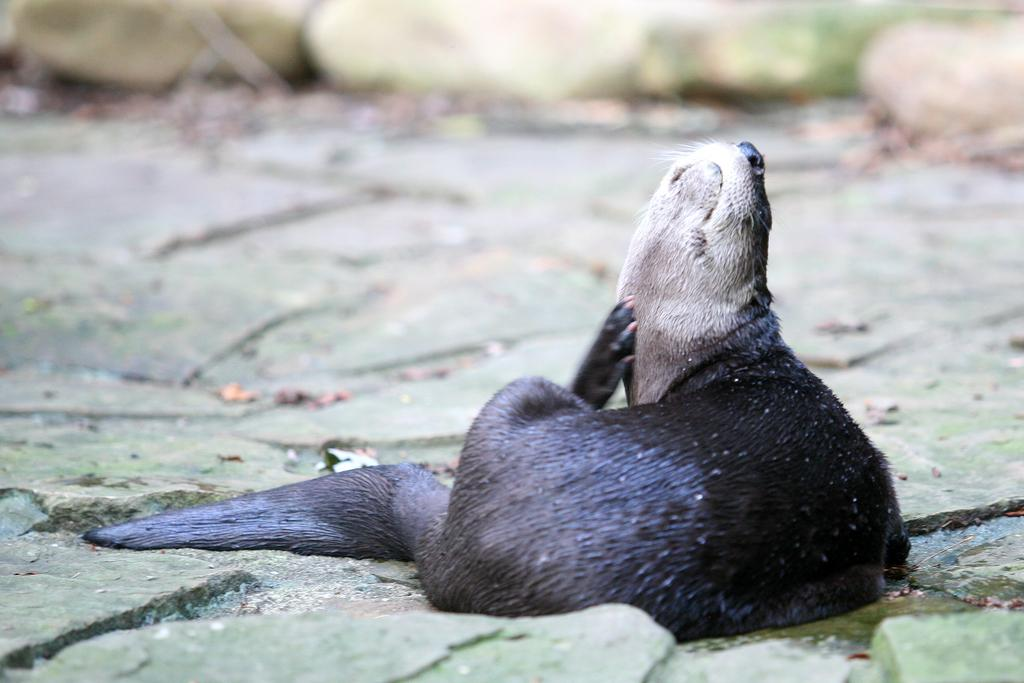What type of animal is in the image? There is a California sea lion in the image. What is the sea lion sitting on? The sea lion is sitting on green color stones. Can you describe the background of the image? The background of the image is blurred. Where might this image have been taken? The image might have been taken in a zoo. What shape is the spoon that the sea lion is holding in the image? There is no spoon present in the image; the sea lion is sitting on green color stones. How many circles can be seen in the image? There are no circles visible in the image, as it features a California sea lion sitting on green color stones with a blurred background. 